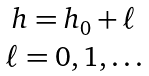Convert formula to latex. <formula><loc_0><loc_0><loc_500><loc_500>\begin{matrix} h = h _ { 0 } + \ell \\ \ell = 0 , 1 , \dots \end{matrix}</formula> 